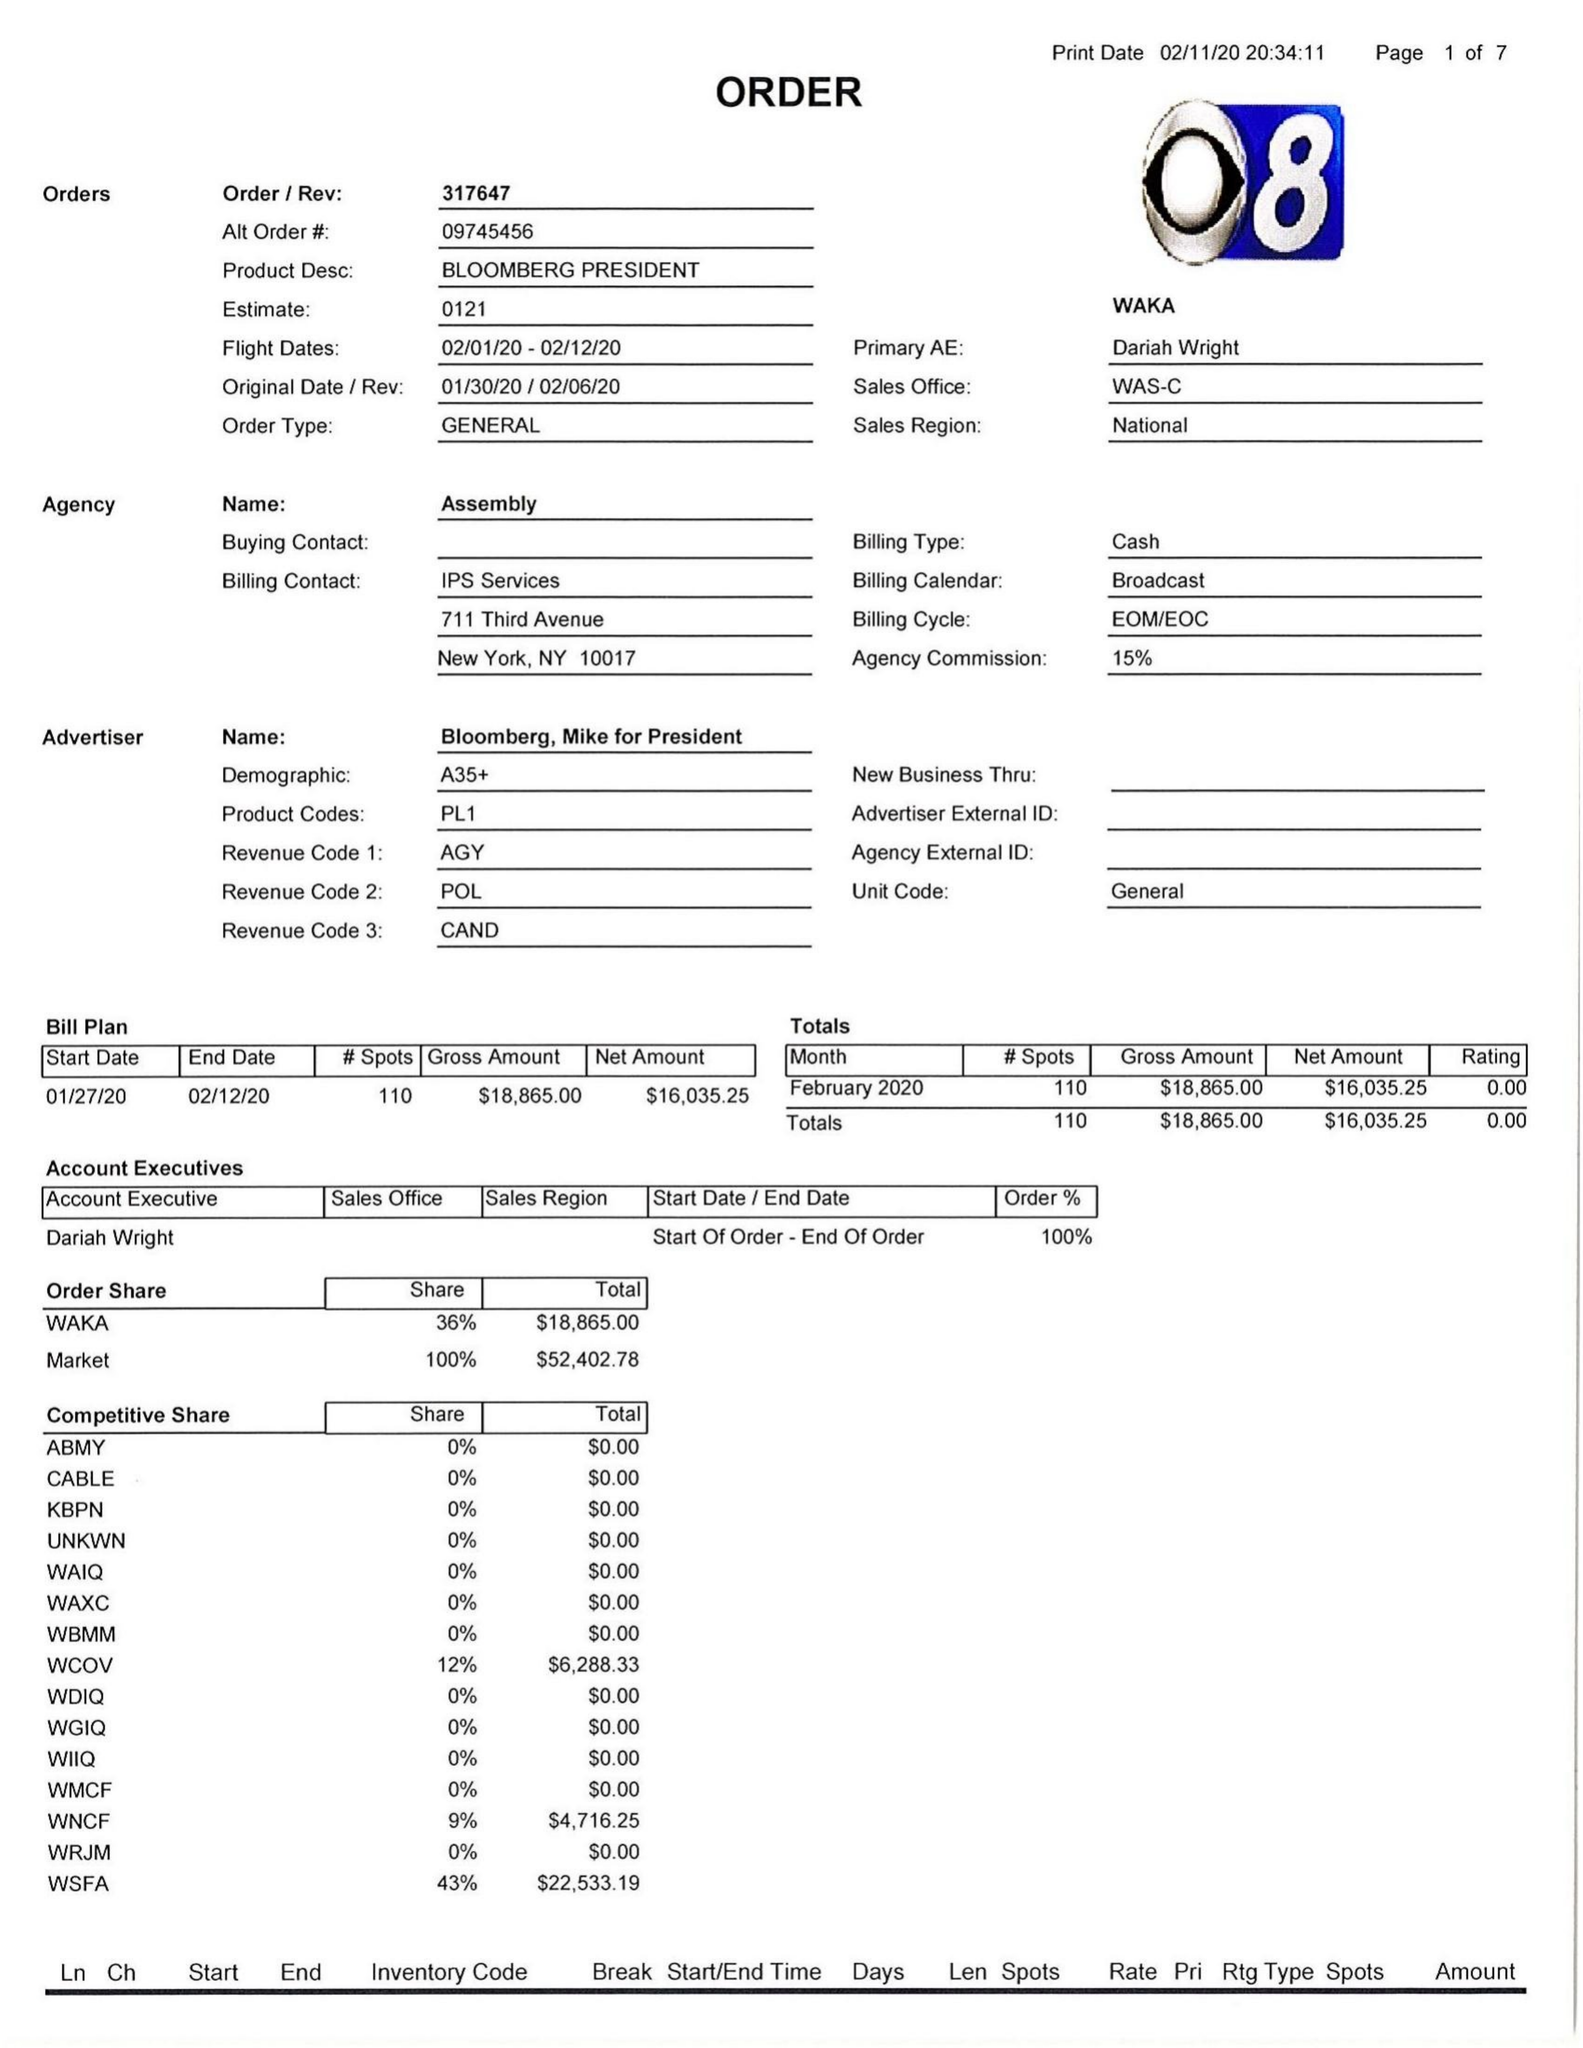What is the value for the contract_num?
Answer the question using a single word or phrase. 317647 